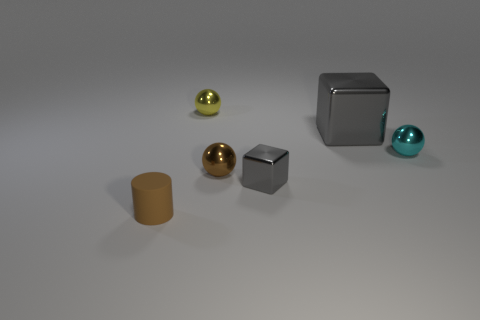There is another cube that is the same color as the small cube; what size is it?
Offer a very short reply. Large. What number of tiny yellow balls are made of the same material as the big object?
Your response must be concise. 1. The tiny cube that is the same material as the yellow sphere is what color?
Provide a succinct answer. Gray. Is the size of the brown cylinder the same as the brown thing to the right of the small yellow metal sphere?
Offer a very short reply. Yes. What material is the cube that is in front of the small brown object to the right of the small cylinder that is left of the small gray metal object?
Ensure brevity in your answer.  Metal. What number of objects are brown things or small metal blocks?
Offer a terse response. 3. There is a tiny sphere that is behind the big gray thing; is it the same color as the block that is in front of the cyan metal thing?
Your answer should be very brief. No. What is the shape of the gray metallic object that is the same size as the cyan metal sphere?
Provide a short and direct response. Cube. How many things are small things on the right side of the tiny yellow metal thing or spheres right of the small cube?
Make the answer very short. 3. Are there fewer tiny gray blocks than small metallic things?
Provide a short and direct response. Yes. 